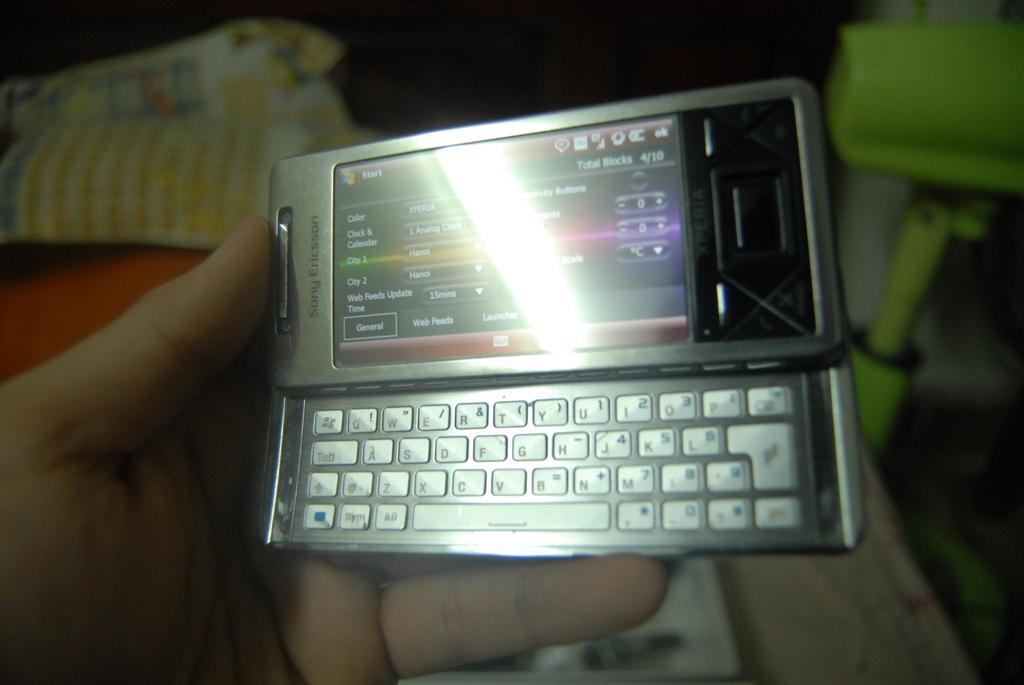Please provide a concise description of this image. In this picture we can see a person hand is holding a mobile, clothes and some objects and in the background it is dark. 